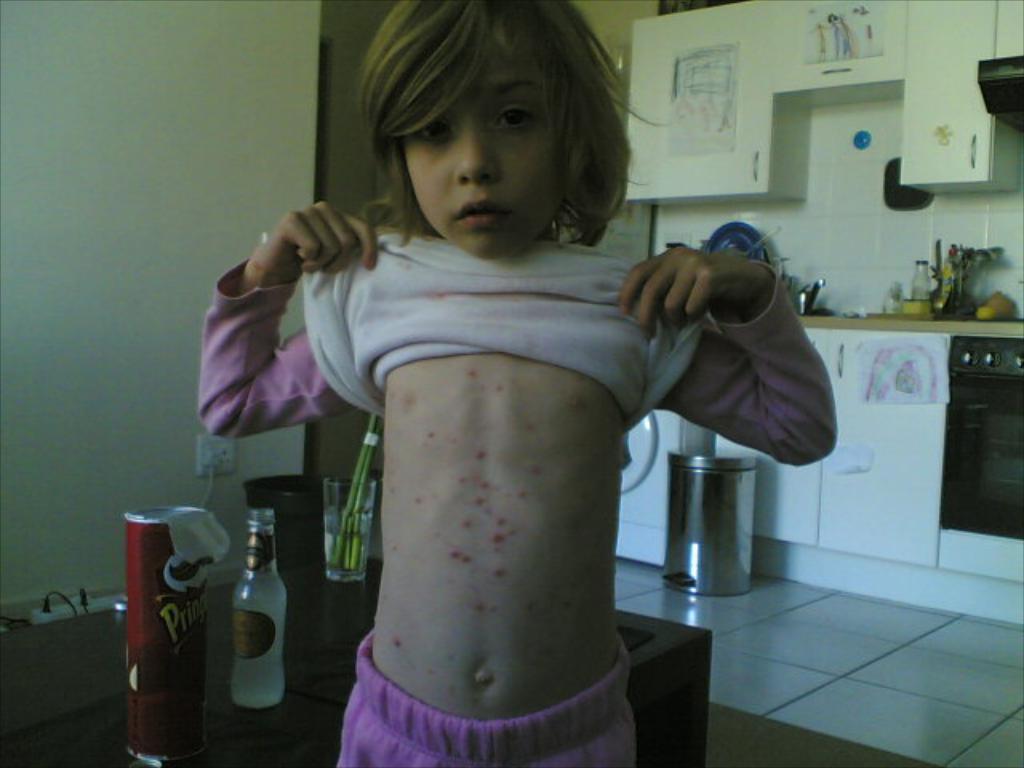In one or two sentences, can you explain what this image depicts? In this picture there is a person standing and holding the dress. On the left side of the image there is a box, bottle, glass, switch board on the table. On the right side of the image there is a sink, bottle and utensils on the desk, at the bottom of the desk there is a cupboard and there is a micro oven. At the top there are cupboards and there are posters on the cupboards. At the bottom there is a dustbin and mat. 